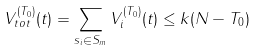Convert formula to latex. <formula><loc_0><loc_0><loc_500><loc_500>V _ { t o t } ^ { ( T _ { 0 } ) } ( t ) = \sum _ { s _ { i } \in S _ { m } } V _ { i } ^ { ( T _ { 0 } ) } ( t ) \leq k ( N - T _ { 0 } )</formula> 